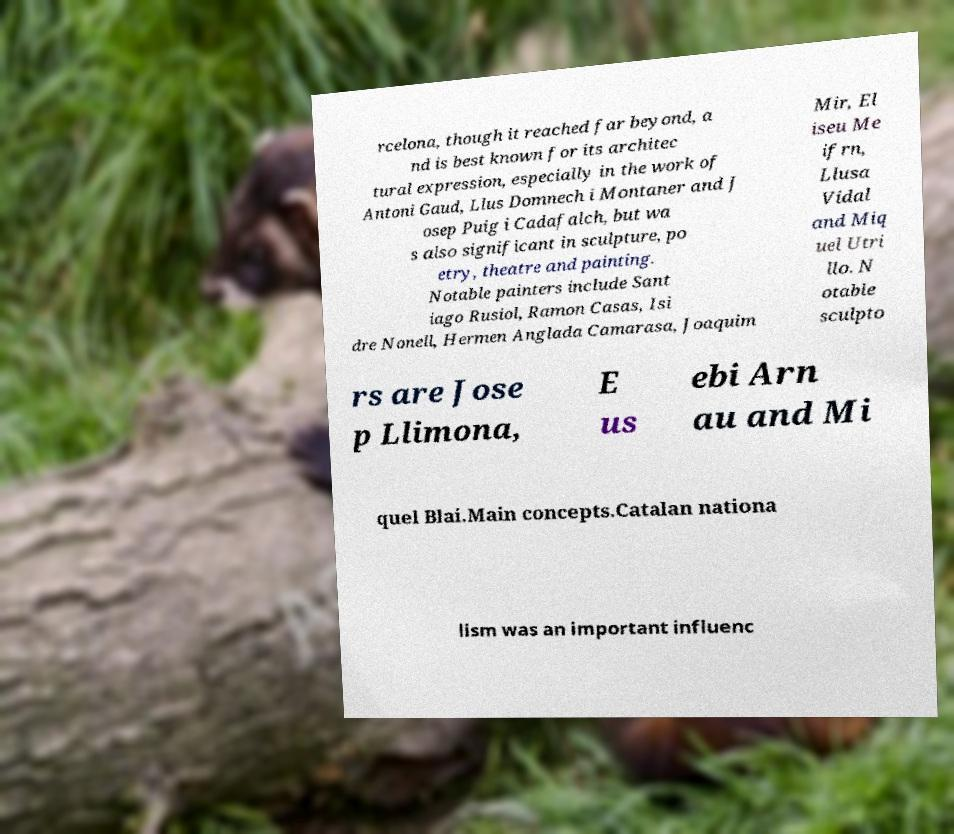There's text embedded in this image that I need extracted. Can you transcribe it verbatim? rcelona, though it reached far beyond, a nd is best known for its architec tural expression, especially in the work of Antoni Gaud, Llus Domnech i Montaner and J osep Puig i Cadafalch, but wa s also significant in sculpture, po etry, theatre and painting. Notable painters include Sant iago Rusiol, Ramon Casas, Isi dre Nonell, Hermen Anglada Camarasa, Joaquim Mir, El iseu Me ifrn, Llusa Vidal and Miq uel Utri llo. N otable sculpto rs are Jose p Llimona, E us ebi Arn au and Mi quel Blai.Main concepts.Catalan nationa lism was an important influenc 